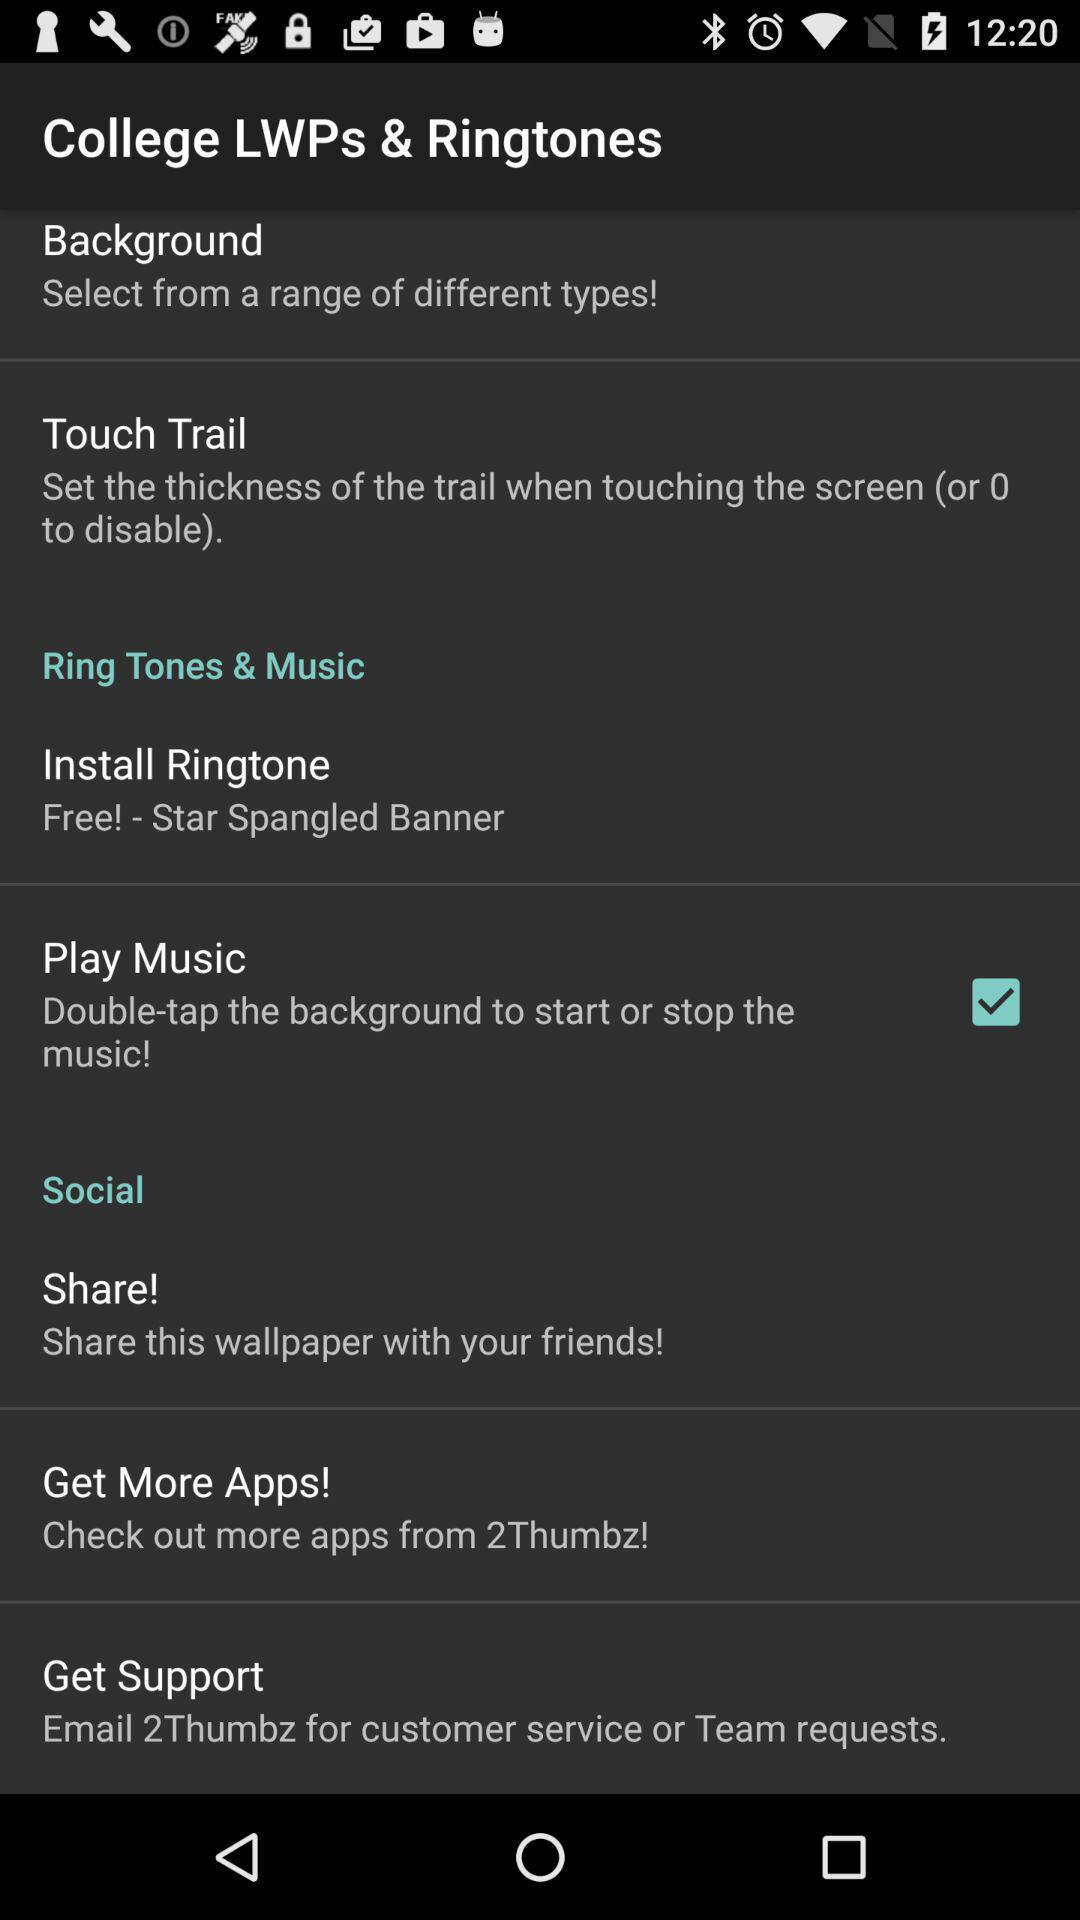How thick is the touch trail?
When the provided information is insufficient, respond with <no answer>. <no answer> 